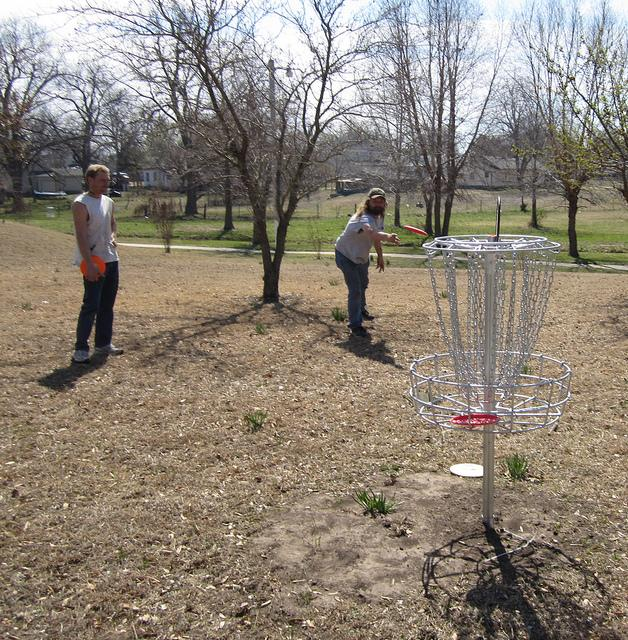What sport are the two men playing? Please explain your reasoning. disc golf. The throw of the ball, by the man shows the type of game being played. 